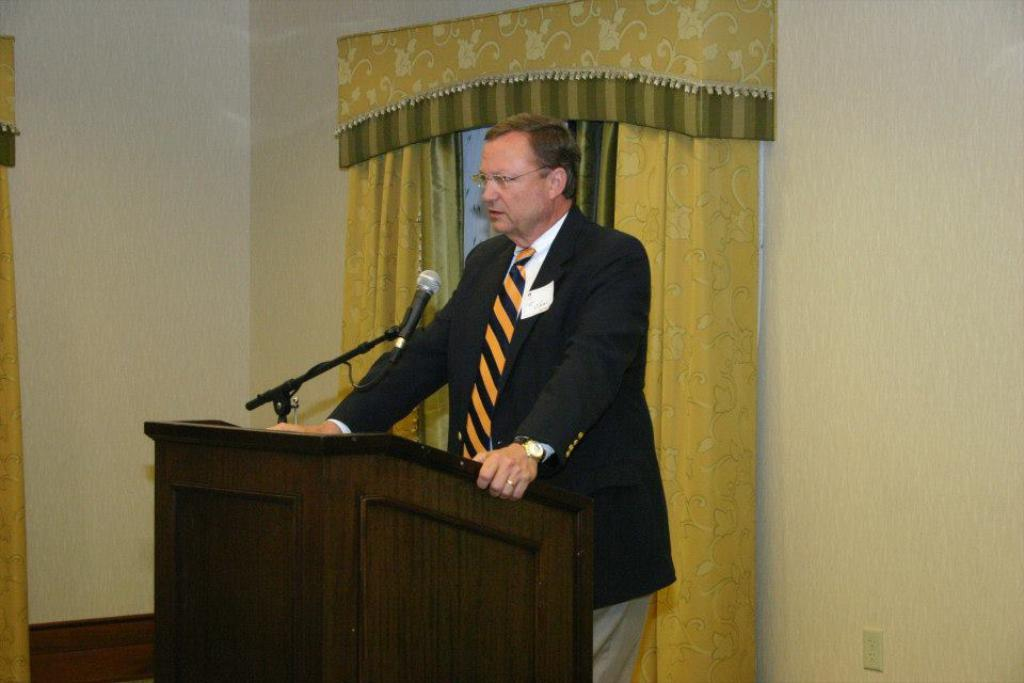What is the man in the image doing? There is a man standing in the image, but his specific activity is not clear. What object is in front of the man? There is a wooden podium in front of the man. What is on the podium? There is a microphone on the podium. What is visible behind the man? There is a wall behind the man. What type of window treatment is present in the image? There are curtains associated with the windows in the image. What type of wine is being served at the event in the image? There is no indication of an event or wine being served in the image. How many cherries are on the man's plate in the image? There is no plate or cherries present in the image. 